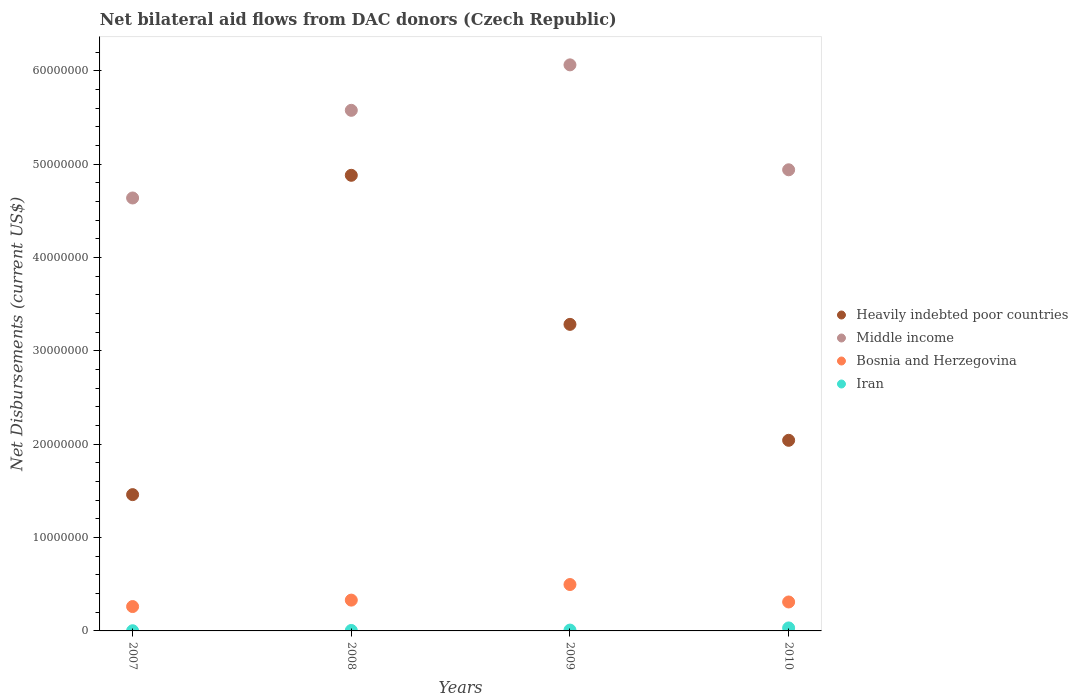What is the net bilateral aid flows in Middle income in 2010?
Give a very brief answer. 4.94e+07. Across all years, what is the maximum net bilateral aid flows in Iran?
Offer a very short reply. 3.20e+05. Across all years, what is the minimum net bilateral aid flows in Heavily indebted poor countries?
Provide a succinct answer. 1.46e+07. In which year was the net bilateral aid flows in Middle income maximum?
Your answer should be very brief. 2009. In which year was the net bilateral aid flows in Bosnia and Herzegovina minimum?
Make the answer very short. 2007. What is the total net bilateral aid flows in Iran in the graph?
Offer a very short reply. 4.80e+05. What is the difference between the net bilateral aid flows in Bosnia and Herzegovina in 2007 and that in 2008?
Ensure brevity in your answer.  -6.90e+05. What is the difference between the net bilateral aid flows in Iran in 2010 and the net bilateral aid flows in Bosnia and Herzegovina in 2008?
Keep it short and to the point. -2.98e+06. In the year 2009, what is the difference between the net bilateral aid flows in Middle income and net bilateral aid flows in Heavily indebted poor countries?
Make the answer very short. 2.78e+07. In how many years, is the net bilateral aid flows in Bosnia and Herzegovina greater than 24000000 US$?
Make the answer very short. 0. What is the ratio of the net bilateral aid flows in Heavily indebted poor countries in 2009 to that in 2010?
Ensure brevity in your answer.  1.61. Is the net bilateral aid flows in Middle income in 2008 less than that in 2010?
Your answer should be compact. No. Is the difference between the net bilateral aid flows in Middle income in 2008 and 2010 greater than the difference between the net bilateral aid flows in Heavily indebted poor countries in 2008 and 2010?
Give a very brief answer. No. What is the difference between the highest and the second highest net bilateral aid flows in Heavily indebted poor countries?
Your response must be concise. 1.60e+07. What is the difference between the highest and the lowest net bilateral aid flows in Heavily indebted poor countries?
Provide a succinct answer. 3.42e+07. Does the graph contain grids?
Ensure brevity in your answer.  No. Where does the legend appear in the graph?
Provide a succinct answer. Center right. How many legend labels are there?
Make the answer very short. 4. How are the legend labels stacked?
Your response must be concise. Vertical. What is the title of the graph?
Give a very brief answer. Net bilateral aid flows from DAC donors (Czech Republic). What is the label or title of the X-axis?
Your response must be concise. Years. What is the label or title of the Y-axis?
Provide a succinct answer. Net Disbursements (current US$). What is the Net Disbursements (current US$) of Heavily indebted poor countries in 2007?
Your response must be concise. 1.46e+07. What is the Net Disbursements (current US$) in Middle income in 2007?
Offer a very short reply. 4.64e+07. What is the Net Disbursements (current US$) in Bosnia and Herzegovina in 2007?
Provide a short and direct response. 2.61e+06. What is the Net Disbursements (current US$) of Iran in 2007?
Offer a very short reply. 2.00e+04. What is the Net Disbursements (current US$) of Heavily indebted poor countries in 2008?
Keep it short and to the point. 4.88e+07. What is the Net Disbursements (current US$) of Middle income in 2008?
Your response must be concise. 5.58e+07. What is the Net Disbursements (current US$) of Bosnia and Herzegovina in 2008?
Provide a short and direct response. 3.30e+06. What is the Net Disbursements (current US$) in Iran in 2008?
Your answer should be compact. 5.00e+04. What is the Net Disbursements (current US$) in Heavily indebted poor countries in 2009?
Your response must be concise. 3.28e+07. What is the Net Disbursements (current US$) in Middle income in 2009?
Your response must be concise. 6.06e+07. What is the Net Disbursements (current US$) of Bosnia and Herzegovina in 2009?
Provide a succinct answer. 4.97e+06. What is the Net Disbursements (current US$) of Iran in 2009?
Give a very brief answer. 9.00e+04. What is the Net Disbursements (current US$) of Heavily indebted poor countries in 2010?
Make the answer very short. 2.04e+07. What is the Net Disbursements (current US$) in Middle income in 2010?
Keep it short and to the point. 4.94e+07. What is the Net Disbursements (current US$) of Bosnia and Herzegovina in 2010?
Your response must be concise. 3.10e+06. What is the Net Disbursements (current US$) of Iran in 2010?
Offer a very short reply. 3.20e+05. Across all years, what is the maximum Net Disbursements (current US$) of Heavily indebted poor countries?
Ensure brevity in your answer.  4.88e+07. Across all years, what is the maximum Net Disbursements (current US$) in Middle income?
Ensure brevity in your answer.  6.06e+07. Across all years, what is the maximum Net Disbursements (current US$) in Bosnia and Herzegovina?
Provide a short and direct response. 4.97e+06. Across all years, what is the maximum Net Disbursements (current US$) of Iran?
Ensure brevity in your answer.  3.20e+05. Across all years, what is the minimum Net Disbursements (current US$) of Heavily indebted poor countries?
Provide a short and direct response. 1.46e+07. Across all years, what is the minimum Net Disbursements (current US$) in Middle income?
Offer a very short reply. 4.64e+07. Across all years, what is the minimum Net Disbursements (current US$) of Bosnia and Herzegovina?
Your response must be concise. 2.61e+06. What is the total Net Disbursements (current US$) in Heavily indebted poor countries in the graph?
Ensure brevity in your answer.  1.17e+08. What is the total Net Disbursements (current US$) of Middle income in the graph?
Your response must be concise. 2.12e+08. What is the total Net Disbursements (current US$) of Bosnia and Herzegovina in the graph?
Provide a succinct answer. 1.40e+07. What is the total Net Disbursements (current US$) of Iran in the graph?
Provide a succinct answer. 4.80e+05. What is the difference between the Net Disbursements (current US$) of Heavily indebted poor countries in 2007 and that in 2008?
Give a very brief answer. -3.42e+07. What is the difference between the Net Disbursements (current US$) of Middle income in 2007 and that in 2008?
Make the answer very short. -9.39e+06. What is the difference between the Net Disbursements (current US$) in Bosnia and Herzegovina in 2007 and that in 2008?
Your answer should be compact. -6.90e+05. What is the difference between the Net Disbursements (current US$) in Heavily indebted poor countries in 2007 and that in 2009?
Provide a succinct answer. -1.82e+07. What is the difference between the Net Disbursements (current US$) in Middle income in 2007 and that in 2009?
Offer a very short reply. -1.43e+07. What is the difference between the Net Disbursements (current US$) in Bosnia and Herzegovina in 2007 and that in 2009?
Offer a terse response. -2.36e+06. What is the difference between the Net Disbursements (current US$) of Heavily indebted poor countries in 2007 and that in 2010?
Make the answer very short. -5.82e+06. What is the difference between the Net Disbursements (current US$) in Middle income in 2007 and that in 2010?
Keep it short and to the point. -3.02e+06. What is the difference between the Net Disbursements (current US$) in Bosnia and Herzegovina in 2007 and that in 2010?
Keep it short and to the point. -4.90e+05. What is the difference between the Net Disbursements (current US$) in Heavily indebted poor countries in 2008 and that in 2009?
Your response must be concise. 1.60e+07. What is the difference between the Net Disbursements (current US$) of Middle income in 2008 and that in 2009?
Offer a very short reply. -4.87e+06. What is the difference between the Net Disbursements (current US$) in Bosnia and Herzegovina in 2008 and that in 2009?
Your response must be concise. -1.67e+06. What is the difference between the Net Disbursements (current US$) of Iran in 2008 and that in 2009?
Your response must be concise. -4.00e+04. What is the difference between the Net Disbursements (current US$) of Heavily indebted poor countries in 2008 and that in 2010?
Offer a very short reply. 2.84e+07. What is the difference between the Net Disbursements (current US$) of Middle income in 2008 and that in 2010?
Offer a very short reply. 6.37e+06. What is the difference between the Net Disbursements (current US$) in Iran in 2008 and that in 2010?
Give a very brief answer. -2.70e+05. What is the difference between the Net Disbursements (current US$) of Heavily indebted poor countries in 2009 and that in 2010?
Make the answer very short. 1.24e+07. What is the difference between the Net Disbursements (current US$) in Middle income in 2009 and that in 2010?
Offer a very short reply. 1.12e+07. What is the difference between the Net Disbursements (current US$) in Bosnia and Herzegovina in 2009 and that in 2010?
Provide a short and direct response. 1.87e+06. What is the difference between the Net Disbursements (current US$) of Iran in 2009 and that in 2010?
Ensure brevity in your answer.  -2.30e+05. What is the difference between the Net Disbursements (current US$) of Heavily indebted poor countries in 2007 and the Net Disbursements (current US$) of Middle income in 2008?
Your answer should be very brief. -4.12e+07. What is the difference between the Net Disbursements (current US$) in Heavily indebted poor countries in 2007 and the Net Disbursements (current US$) in Bosnia and Herzegovina in 2008?
Your answer should be compact. 1.13e+07. What is the difference between the Net Disbursements (current US$) in Heavily indebted poor countries in 2007 and the Net Disbursements (current US$) in Iran in 2008?
Offer a terse response. 1.46e+07. What is the difference between the Net Disbursements (current US$) of Middle income in 2007 and the Net Disbursements (current US$) of Bosnia and Herzegovina in 2008?
Make the answer very short. 4.31e+07. What is the difference between the Net Disbursements (current US$) in Middle income in 2007 and the Net Disbursements (current US$) in Iran in 2008?
Offer a terse response. 4.63e+07. What is the difference between the Net Disbursements (current US$) of Bosnia and Herzegovina in 2007 and the Net Disbursements (current US$) of Iran in 2008?
Make the answer very short. 2.56e+06. What is the difference between the Net Disbursements (current US$) in Heavily indebted poor countries in 2007 and the Net Disbursements (current US$) in Middle income in 2009?
Give a very brief answer. -4.60e+07. What is the difference between the Net Disbursements (current US$) of Heavily indebted poor countries in 2007 and the Net Disbursements (current US$) of Bosnia and Herzegovina in 2009?
Keep it short and to the point. 9.63e+06. What is the difference between the Net Disbursements (current US$) in Heavily indebted poor countries in 2007 and the Net Disbursements (current US$) in Iran in 2009?
Give a very brief answer. 1.45e+07. What is the difference between the Net Disbursements (current US$) of Middle income in 2007 and the Net Disbursements (current US$) of Bosnia and Herzegovina in 2009?
Your answer should be very brief. 4.14e+07. What is the difference between the Net Disbursements (current US$) of Middle income in 2007 and the Net Disbursements (current US$) of Iran in 2009?
Offer a terse response. 4.63e+07. What is the difference between the Net Disbursements (current US$) of Bosnia and Herzegovina in 2007 and the Net Disbursements (current US$) of Iran in 2009?
Your answer should be very brief. 2.52e+06. What is the difference between the Net Disbursements (current US$) in Heavily indebted poor countries in 2007 and the Net Disbursements (current US$) in Middle income in 2010?
Provide a succinct answer. -3.48e+07. What is the difference between the Net Disbursements (current US$) of Heavily indebted poor countries in 2007 and the Net Disbursements (current US$) of Bosnia and Herzegovina in 2010?
Your answer should be very brief. 1.15e+07. What is the difference between the Net Disbursements (current US$) of Heavily indebted poor countries in 2007 and the Net Disbursements (current US$) of Iran in 2010?
Offer a very short reply. 1.43e+07. What is the difference between the Net Disbursements (current US$) of Middle income in 2007 and the Net Disbursements (current US$) of Bosnia and Herzegovina in 2010?
Provide a succinct answer. 4.33e+07. What is the difference between the Net Disbursements (current US$) in Middle income in 2007 and the Net Disbursements (current US$) in Iran in 2010?
Offer a terse response. 4.61e+07. What is the difference between the Net Disbursements (current US$) in Bosnia and Herzegovina in 2007 and the Net Disbursements (current US$) in Iran in 2010?
Keep it short and to the point. 2.29e+06. What is the difference between the Net Disbursements (current US$) of Heavily indebted poor countries in 2008 and the Net Disbursements (current US$) of Middle income in 2009?
Make the answer very short. -1.18e+07. What is the difference between the Net Disbursements (current US$) in Heavily indebted poor countries in 2008 and the Net Disbursements (current US$) in Bosnia and Herzegovina in 2009?
Your answer should be compact. 4.38e+07. What is the difference between the Net Disbursements (current US$) of Heavily indebted poor countries in 2008 and the Net Disbursements (current US$) of Iran in 2009?
Provide a short and direct response. 4.87e+07. What is the difference between the Net Disbursements (current US$) of Middle income in 2008 and the Net Disbursements (current US$) of Bosnia and Herzegovina in 2009?
Your answer should be compact. 5.08e+07. What is the difference between the Net Disbursements (current US$) in Middle income in 2008 and the Net Disbursements (current US$) in Iran in 2009?
Your response must be concise. 5.57e+07. What is the difference between the Net Disbursements (current US$) in Bosnia and Herzegovina in 2008 and the Net Disbursements (current US$) in Iran in 2009?
Make the answer very short. 3.21e+06. What is the difference between the Net Disbursements (current US$) of Heavily indebted poor countries in 2008 and the Net Disbursements (current US$) of Middle income in 2010?
Make the answer very short. -5.90e+05. What is the difference between the Net Disbursements (current US$) in Heavily indebted poor countries in 2008 and the Net Disbursements (current US$) in Bosnia and Herzegovina in 2010?
Your response must be concise. 4.57e+07. What is the difference between the Net Disbursements (current US$) in Heavily indebted poor countries in 2008 and the Net Disbursements (current US$) in Iran in 2010?
Offer a terse response. 4.85e+07. What is the difference between the Net Disbursements (current US$) in Middle income in 2008 and the Net Disbursements (current US$) in Bosnia and Herzegovina in 2010?
Offer a very short reply. 5.27e+07. What is the difference between the Net Disbursements (current US$) of Middle income in 2008 and the Net Disbursements (current US$) of Iran in 2010?
Your response must be concise. 5.54e+07. What is the difference between the Net Disbursements (current US$) of Bosnia and Herzegovina in 2008 and the Net Disbursements (current US$) of Iran in 2010?
Keep it short and to the point. 2.98e+06. What is the difference between the Net Disbursements (current US$) in Heavily indebted poor countries in 2009 and the Net Disbursements (current US$) in Middle income in 2010?
Ensure brevity in your answer.  -1.66e+07. What is the difference between the Net Disbursements (current US$) in Heavily indebted poor countries in 2009 and the Net Disbursements (current US$) in Bosnia and Herzegovina in 2010?
Offer a very short reply. 2.97e+07. What is the difference between the Net Disbursements (current US$) of Heavily indebted poor countries in 2009 and the Net Disbursements (current US$) of Iran in 2010?
Offer a very short reply. 3.25e+07. What is the difference between the Net Disbursements (current US$) in Middle income in 2009 and the Net Disbursements (current US$) in Bosnia and Herzegovina in 2010?
Ensure brevity in your answer.  5.75e+07. What is the difference between the Net Disbursements (current US$) of Middle income in 2009 and the Net Disbursements (current US$) of Iran in 2010?
Ensure brevity in your answer.  6.03e+07. What is the difference between the Net Disbursements (current US$) in Bosnia and Herzegovina in 2009 and the Net Disbursements (current US$) in Iran in 2010?
Offer a very short reply. 4.65e+06. What is the average Net Disbursements (current US$) of Heavily indebted poor countries per year?
Your response must be concise. 2.92e+07. What is the average Net Disbursements (current US$) of Middle income per year?
Offer a terse response. 5.30e+07. What is the average Net Disbursements (current US$) of Bosnia and Herzegovina per year?
Make the answer very short. 3.50e+06. What is the average Net Disbursements (current US$) in Iran per year?
Offer a very short reply. 1.20e+05. In the year 2007, what is the difference between the Net Disbursements (current US$) in Heavily indebted poor countries and Net Disbursements (current US$) in Middle income?
Your answer should be very brief. -3.18e+07. In the year 2007, what is the difference between the Net Disbursements (current US$) in Heavily indebted poor countries and Net Disbursements (current US$) in Bosnia and Herzegovina?
Provide a succinct answer. 1.20e+07. In the year 2007, what is the difference between the Net Disbursements (current US$) of Heavily indebted poor countries and Net Disbursements (current US$) of Iran?
Offer a terse response. 1.46e+07. In the year 2007, what is the difference between the Net Disbursements (current US$) of Middle income and Net Disbursements (current US$) of Bosnia and Herzegovina?
Offer a very short reply. 4.38e+07. In the year 2007, what is the difference between the Net Disbursements (current US$) of Middle income and Net Disbursements (current US$) of Iran?
Your response must be concise. 4.64e+07. In the year 2007, what is the difference between the Net Disbursements (current US$) in Bosnia and Herzegovina and Net Disbursements (current US$) in Iran?
Your answer should be compact. 2.59e+06. In the year 2008, what is the difference between the Net Disbursements (current US$) of Heavily indebted poor countries and Net Disbursements (current US$) of Middle income?
Make the answer very short. -6.96e+06. In the year 2008, what is the difference between the Net Disbursements (current US$) of Heavily indebted poor countries and Net Disbursements (current US$) of Bosnia and Herzegovina?
Offer a very short reply. 4.55e+07. In the year 2008, what is the difference between the Net Disbursements (current US$) in Heavily indebted poor countries and Net Disbursements (current US$) in Iran?
Your response must be concise. 4.88e+07. In the year 2008, what is the difference between the Net Disbursements (current US$) in Middle income and Net Disbursements (current US$) in Bosnia and Herzegovina?
Keep it short and to the point. 5.25e+07. In the year 2008, what is the difference between the Net Disbursements (current US$) of Middle income and Net Disbursements (current US$) of Iran?
Provide a succinct answer. 5.57e+07. In the year 2008, what is the difference between the Net Disbursements (current US$) in Bosnia and Herzegovina and Net Disbursements (current US$) in Iran?
Offer a very short reply. 3.25e+06. In the year 2009, what is the difference between the Net Disbursements (current US$) in Heavily indebted poor countries and Net Disbursements (current US$) in Middle income?
Ensure brevity in your answer.  -2.78e+07. In the year 2009, what is the difference between the Net Disbursements (current US$) of Heavily indebted poor countries and Net Disbursements (current US$) of Bosnia and Herzegovina?
Your response must be concise. 2.79e+07. In the year 2009, what is the difference between the Net Disbursements (current US$) of Heavily indebted poor countries and Net Disbursements (current US$) of Iran?
Offer a terse response. 3.28e+07. In the year 2009, what is the difference between the Net Disbursements (current US$) of Middle income and Net Disbursements (current US$) of Bosnia and Herzegovina?
Your response must be concise. 5.57e+07. In the year 2009, what is the difference between the Net Disbursements (current US$) in Middle income and Net Disbursements (current US$) in Iran?
Give a very brief answer. 6.06e+07. In the year 2009, what is the difference between the Net Disbursements (current US$) in Bosnia and Herzegovina and Net Disbursements (current US$) in Iran?
Your answer should be compact. 4.88e+06. In the year 2010, what is the difference between the Net Disbursements (current US$) in Heavily indebted poor countries and Net Disbursements (current US$) in Middle income?
Your answer should be compact. -2.90e+07. In the year 2010, what is the difference between the Net Disbursements (current US$) of Heavily indebted poor countries and Net Disbursements (current US$) of Bosnia and Herzegovina?
Provide a short and direct response. 1.73e+07. In the year 2010, what is the difference between the Net Disbursements (current US$) of Heavily indebted poor countries and Net Disbursements (current US$) of Iran?
Make the answer very short. 2.01e+07. In the year 2010, what is the difference between the Net Disbursements (current US$) of Middle income and Net Disbursements (current US$) of Bosnia and Herzegovina?
Offer a very short reply. 4.63e+07. In the year 2010, what is the difference between the Net Disbursements (current US$) in Middle income and Net Disbursements (current US$) in Iran?
Provide a succinct answer. 4.91e+07. In the year 2010, what is the difference between the Net Disbursements (current US$) of Bosnia and Herzegovina and Net Disbursements (current US$) of Iran?
Offer a very short reply. 2.78e+06. What is the ratio of the Net Disbursements (current US$) of Heavily indebted poor countries in 2007 to that in 2008?
Your answer should be compact. 0.3. What is the ratio of the Net Disbursements (current US$) of Middle income in 2007 to that in 2008?
Offer a terse response. 0.83. What is the ratio of the Net Disbursements (current US$) of Bosnia and Herzegovina in 2007 to that in 2008?
Keep it short and to the point. 0.79. What is the ratio of the Net Disbursements (current US$) in Heavily indebted poor countries in 2007 to that in 2009?
Your answer should be very brief. 0.44. What is the ratio of the Net Disbursements (current US$) in Middle income in 2007 to that in 2009?
Your response must be concise. 0.76. What is the ratio of the Net Disbursements (current US$) in Bosnia and Herzegovina in 2007 to that in 2009?
Provide a succinct answer. 0.53. What is the ratio of the Net Disbursements (current US$) in Iran in 2007 to that in 2009?
Make the answer very short. 0.22. What is the ratio of the Net Disbursements (current US$) of Heavily indebted poor countries in 2007 to that in 2010?
Provide a short and direct response. 0.71. What is the ratio of the Net Disbursements (current US$) of Middle income in 2007 to that in 2010?
Offer a very short reply. 0.94. What is the ratio of the Net Disbursements (current US$) of Bosnia and Herzegovina in 2007 to that in 2010?
Offer a terse response. 0.84. What is the ratio of the Net Disbursements (current US$) of Iran in 2007 to that in 2010?
Your response must be concise. 0.06. What is the ratio of the Net Disbursements (current US$) in Heavily indebted poor countries in 2008 to that in 2009?
Offer a terse response. 1.49. What is the ratio of the Net Disbursements (current US$) in Middle income in 2008 to that in 2009?
Make the answer very short. 0.92. What is the ratio of the Net Disbursements (current US$) of Bosnia and Herzegovina in 2008 to that in 2009?
Give a very brief answer. 0.66. What is the ratio of the Net Disbursements (current US$) of Iran in 2008 to that in 2009?
Provide a succinct answer. 0.56. What is the ratio of the Net Disbursements (current US$) of Heavily indebted poor countries in 2008 to that in 2010?
Provide a succinct answer. 2.39. What is the ratio of the Net Disbursements (current US$) of Middle income in 2008 to that in 2010?
Offer a very short reply. 1.13. What is the ratio of the Net Disbursements (current US$) in Bosnia and Herzegovina in 2008 to that in 2010?
Provide a succinct answer. 1.06. What is the ratio of the Net Disbursements (current US$) of Iran in 2008 to that in 2010?
Offer a very short reply. 0.16. What is the ratio of the Net Disbursements (current US$) of Heavily indebted poor countries in 2009 to that in 2010?
Ensure brevity in your answer.  1.61. What is the ratio of the Net Disbursements (current US$) in Middle income in 2009 to that in 2010?
Offer a very short reply. 1.23. What is the ratio of the Net Disbursements (current US$) in Bosnia and Herzegovina in 2009 to that in 2010?
Provide a succinct answer. 1.6. What is the ratio of the Net Disbursements (current US$) of Iran in 2009 to that in 2010?
Keep it short and to the point. 0.28. What is the difference between the highest and the second highest Net Disbursements (current US$) in Heavily indebted poor countries?
Offer a very short reply. 1.60e+07. What is the difference between the highest and the second highest Net Disbursements (current US$) in Middle income?
Ensure brevity in your answer.  4.87e+06. What is the difference between the highest and the second highest Net Disbursements (current US$) in Bosnia and Herzegovina?
Your answer should be compact. 1.67e+06. What is the difference between the highest and the second highest Net Disbursements (current US$) of Iran?
Ensure brevity in your answer.  2.30e+05. What is the difference between the highest and the lowest Net Disbursements (current US$) in Heavily indebted poor countries?
Give a very brief answer. 3.42e+07. What is the difference between the highest and the lowest Net Disbursements (current US$) in Middle income?
Give a very brief answer. 1.43e+07. What is the difference between the highest and the lowest Net Disbursements (current US$) of Bosnia and Herzegovina?
Your answer should be compact. 2.36e+06. 